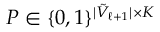<formula> <loc_0><loc_0><loc_500><loc_500>P \in \{ 0 , 1 \} ^ { | \tilde { V } _ { \ell + 1 } | \times K }</formula> 